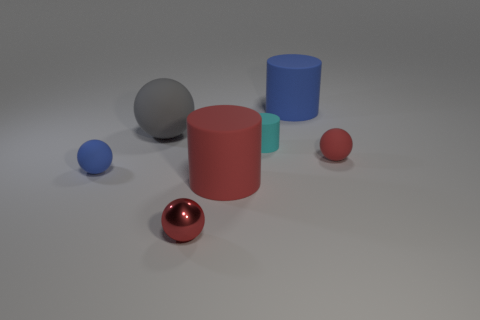The small cyan object that is the same material as the big gray ball is what shape?
Provide a short and direct response. Cylinder. Is there anything else that is the same color as the shiny ball?
Offer a very short reply. Yes. How many small red matte spheres are there?
Ensure brevity in your answer.  1. What is the shape of the tiny matte thing that is in front of the tiny rubber cylinder and on the left side of the tiny red rubber thing?
Your answer should be compact. Sphere. There is a big rubber object to the left of the tiny red ball to the left of the small rubber sphere to the right of the big blue thing; what shape is it?
Make the answer very short. Sphere. What material is the thing that is behind the small cylinder and on the right side of the tiny cylinder?
Provide a succinct answer. Rubber. What number of other rubber cylinders have the same size as the red matte cylinder?
Offer a very short reply. 1. How many matte objects are tiny red things or large gray spheres?
Your response must be concise. 2. What material is the tiny blue sphere?
Provide a short and direct response. Rubber. What number of large matte cylinders are in front of the tiny cyan matte cylinder?
Your answer should be compact. 1. 